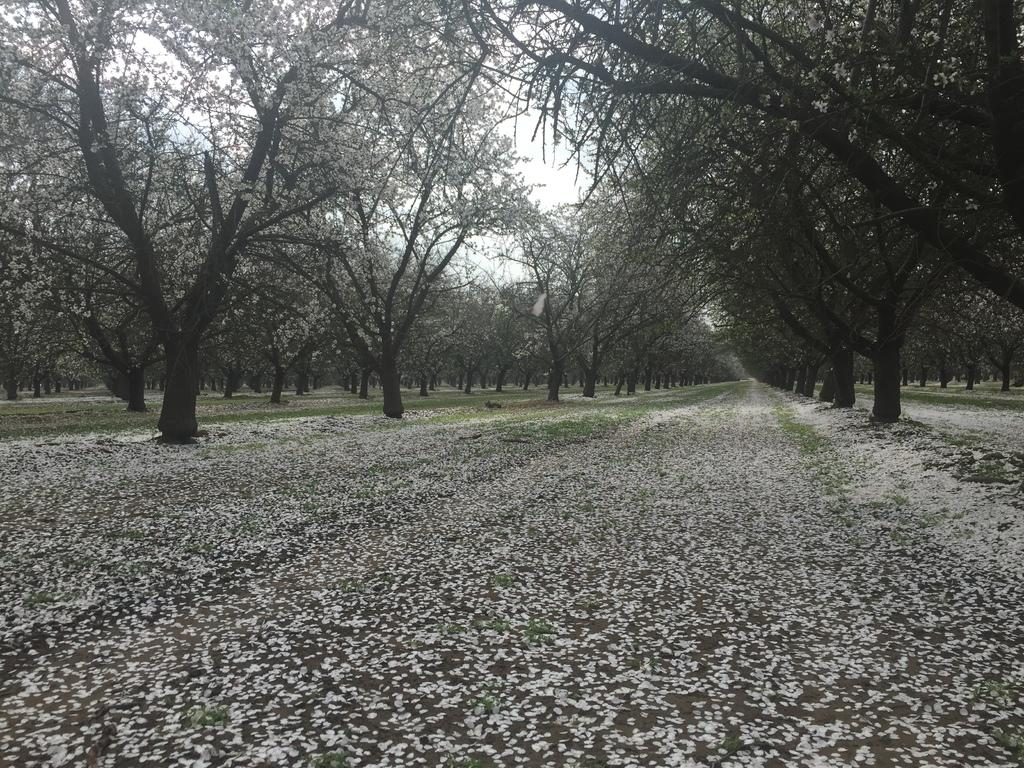What type of vegetation can be seen in the image? There are trees in the image. What part of the natural environment is visible in the image? The sky is visible in the image. What type of fruit is hanging from the trees in the image? There is no fruit visible on the trees in the image. Are there any servants or masked individuals present in the image? There are no servants or masked individuals present in the image; it only features trees and the sky. 